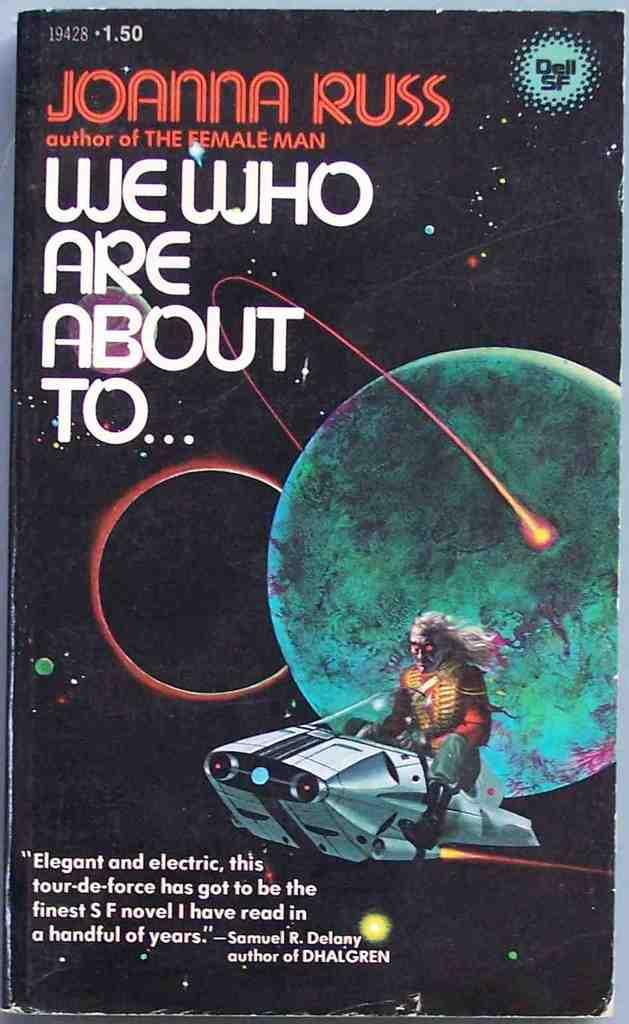<image>
Write a terse but informative summary of the picture. Joanna Russ is the author of We Who Are About To as well as The Female Man. 